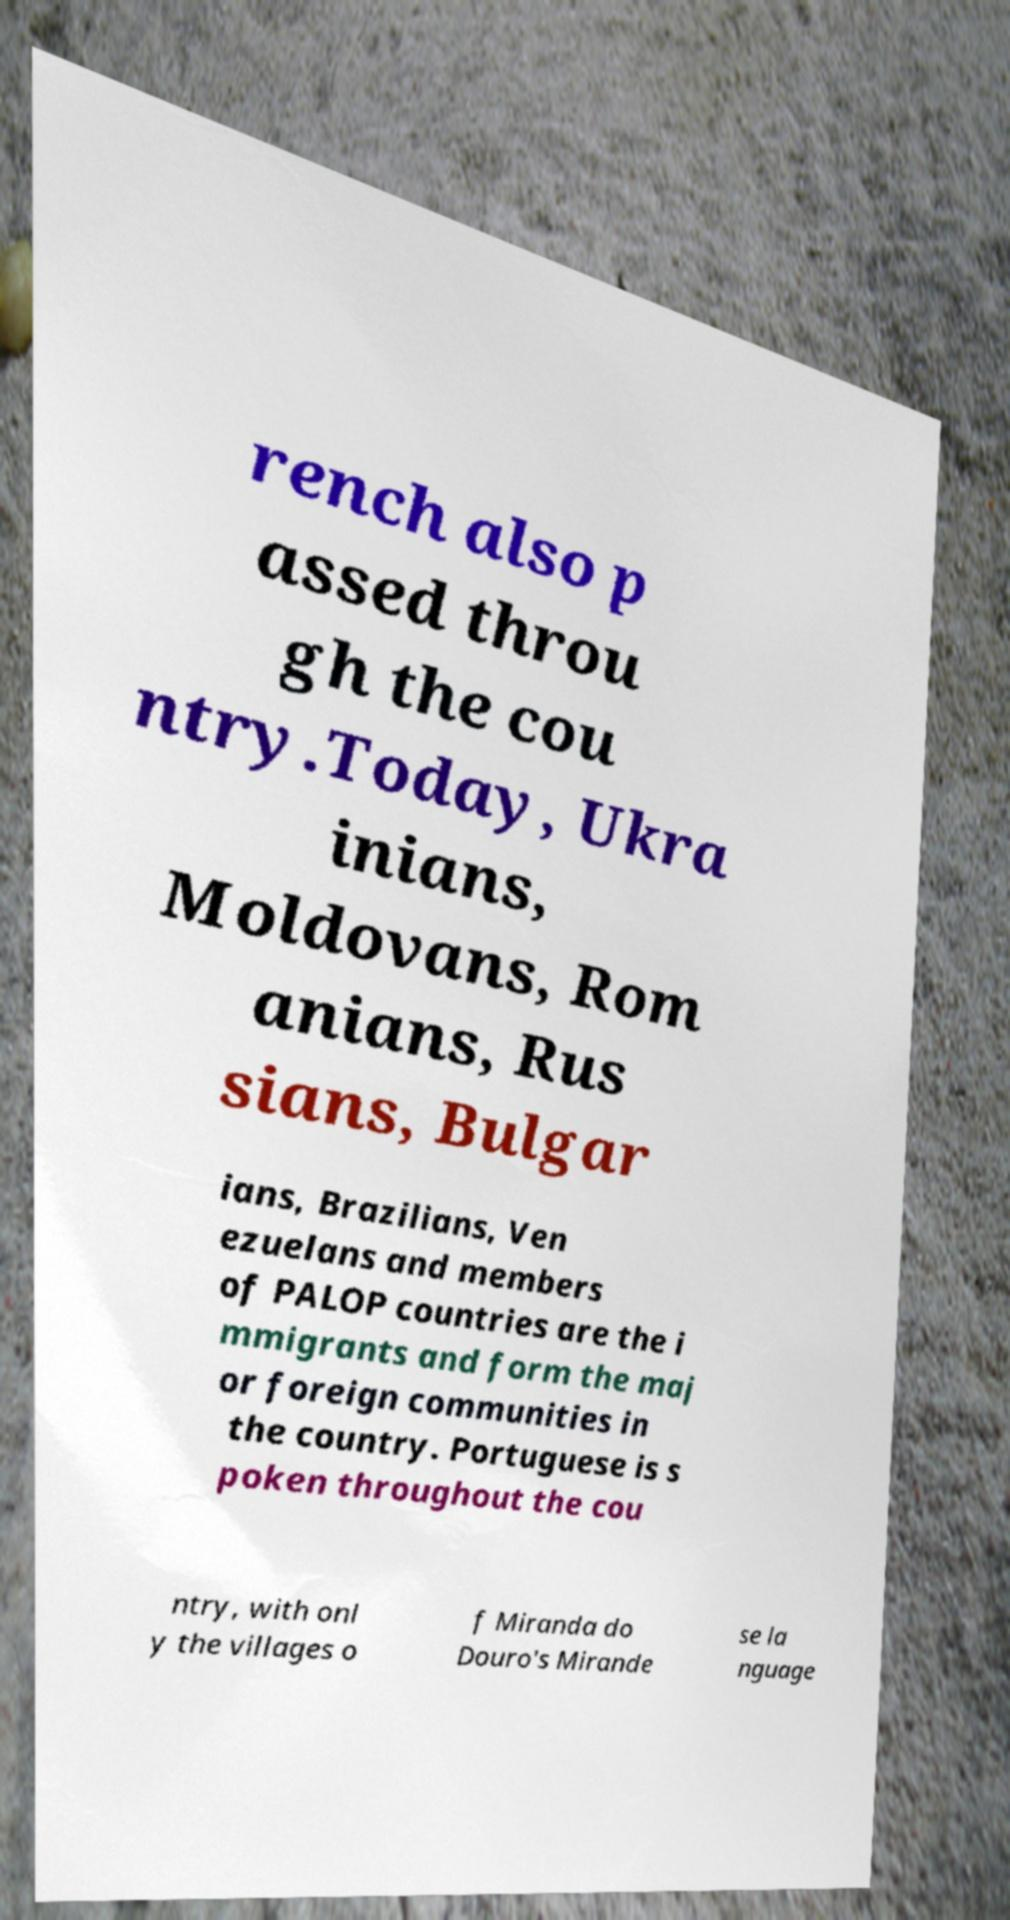Could you assist in decoding the text presented in this image and type it out clearly? rench also p assed throu gh the cou ntry.Today, Ukra inians, Moldovans, Rom anians, Rus sians, Bulgar ians, Brazilians, Ven ezuelans and members of PALOP countries are the i mmigrants and form the maj or foreign communities in the country. Portuguese is s poken throughout the cou ntry, with onl y the villages o f Miranda do Douro's Mirande se la nguage 